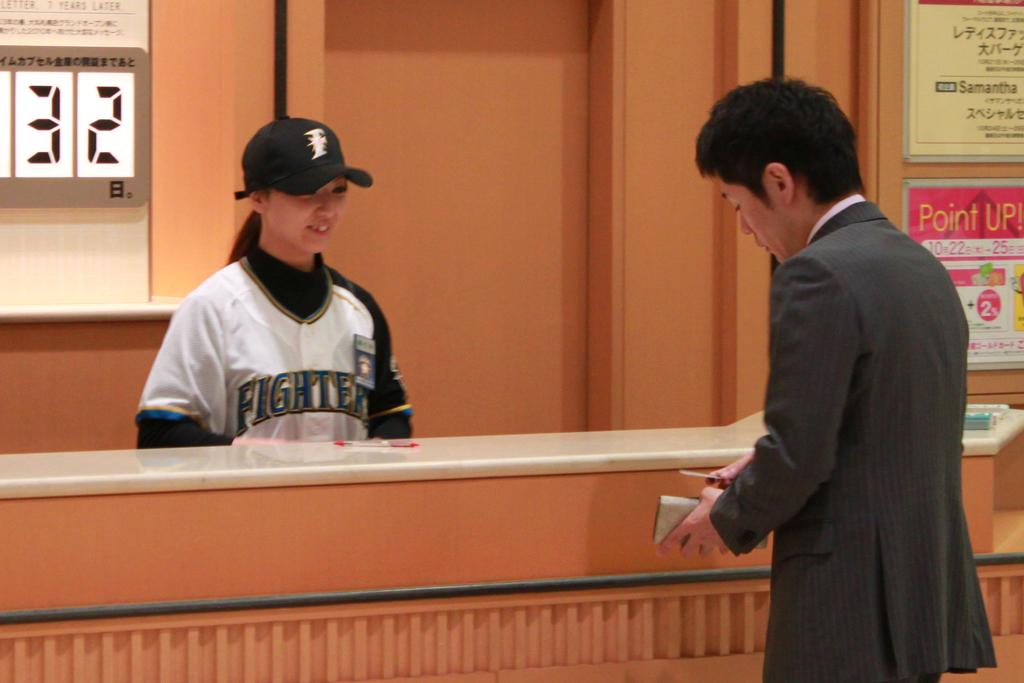<image>
Present a compact description of the photo's key features. Man with a suit is standing in front of a woman with a fighter jersey on 